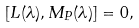Convert formula to latex. <formula><loc_0><loc_0><loc_500><loc_500>[ L ( \lambda ) , M _ { P } ( \lambda ) ] = 0 ,</formula> 